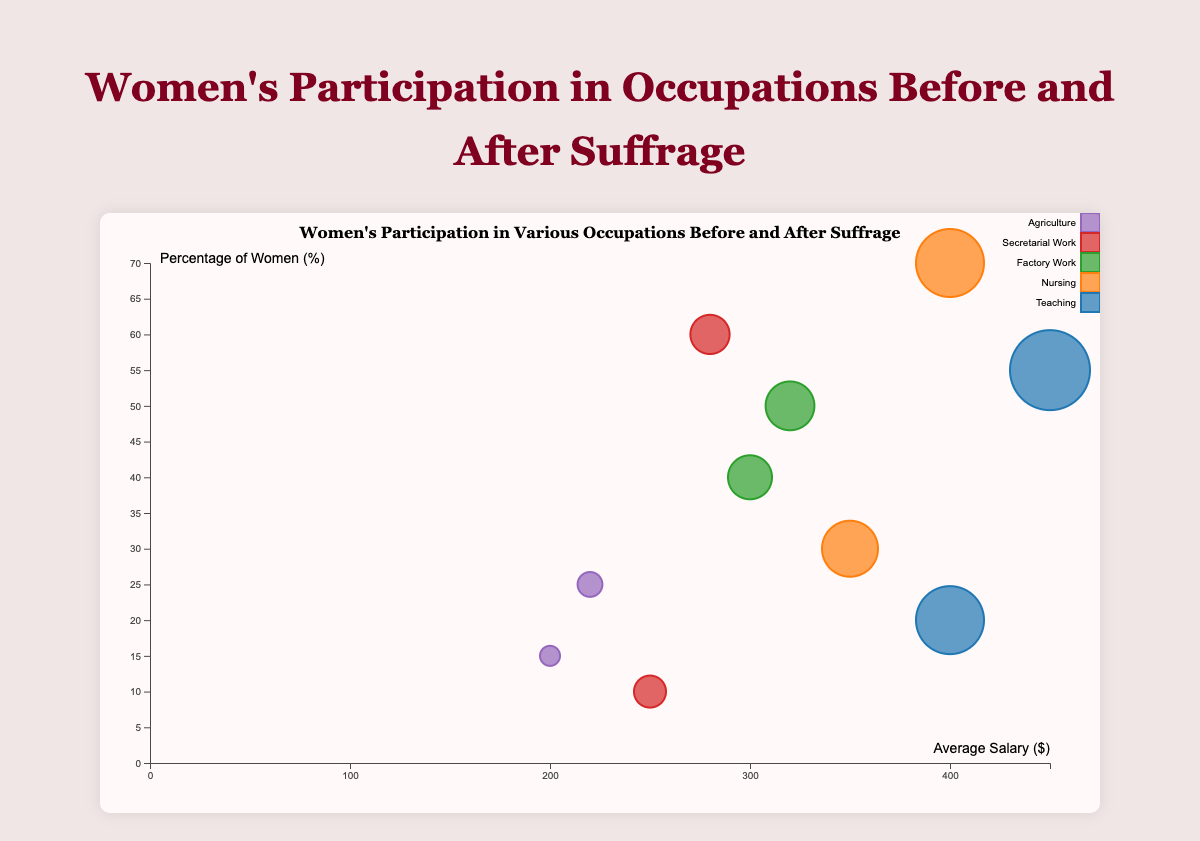What's the title of the chart? The title is usually displayed at the top of the chart. It reads: "Women's Participation in Various Occupations Before and After Suffrage."
Answer: Women's Participation in Various Occupations Before and After Suffrage What does the y-axis represent? The y-axis is labeled with the text "Percentage of Women (%)," indicating that it represents the percentage of women in various occupations.
Answer: Percentage of Women (%) What is the percentage of women in Nursing after suffrage in Illinois? Locate the circle representing Nursing in Illinois after suffrage, then check the y-axis value aligning with it, showing a 70% participation rate.
Answer: 70% Which occupation in California shows the largest increase in women's participation after suffrage? Compare the circles representing before and after suffrage for each occupation in California. Secretarial Work shows a jump from 10% to 60%, which is a 50% increase, the highest among other occupations.
Answer: Secretarial Work What is the average salary for women in Agriculture in Texas after suffrage? Locate the circle representing Agriculture in Texas after suffrage, then check the x-axis value aligning with it, showing an average salary of $220.
Answer: $220 How many occupations increased women’s participation to more than 50% after suffrage? Identify circles representing after suffrage with y-axis values greater than 50%. They are Teaching, Nursing, and Secretarial Work, counting three.
Answer: 3 What is the percentage difference in women's participation in Teaching in New York before and after suffrage? Find the circles representing Teaching in New York before and after suffrage. The before value is 20% and the after value is 55%. The difference is 55% - 20% = 35%.
Answer: 35% What occupation has the highest average salary after suffrage? Compare the x-axis values of all the after suffrage circles to find the highest value. Teaching in New York holds the highest average salary of $450.
Answer: Teaching Between Secretarial Work and Factory Work in California after suffrage, which one has a higher percentage of women? Check the y-axis values for Secretarial Work and Factory Work circles after suffrage in California. Secretarial Work at 60% is higher than Factory Work at 50%.
Answer: Secretarial Work What trend can be observed about women's average salaries after suffrage compared to before in any occupation? Analyzing each pair of before and after circles, each occupation shows an increase in the average salary after suffrage.
Answer: Increased average salaries 